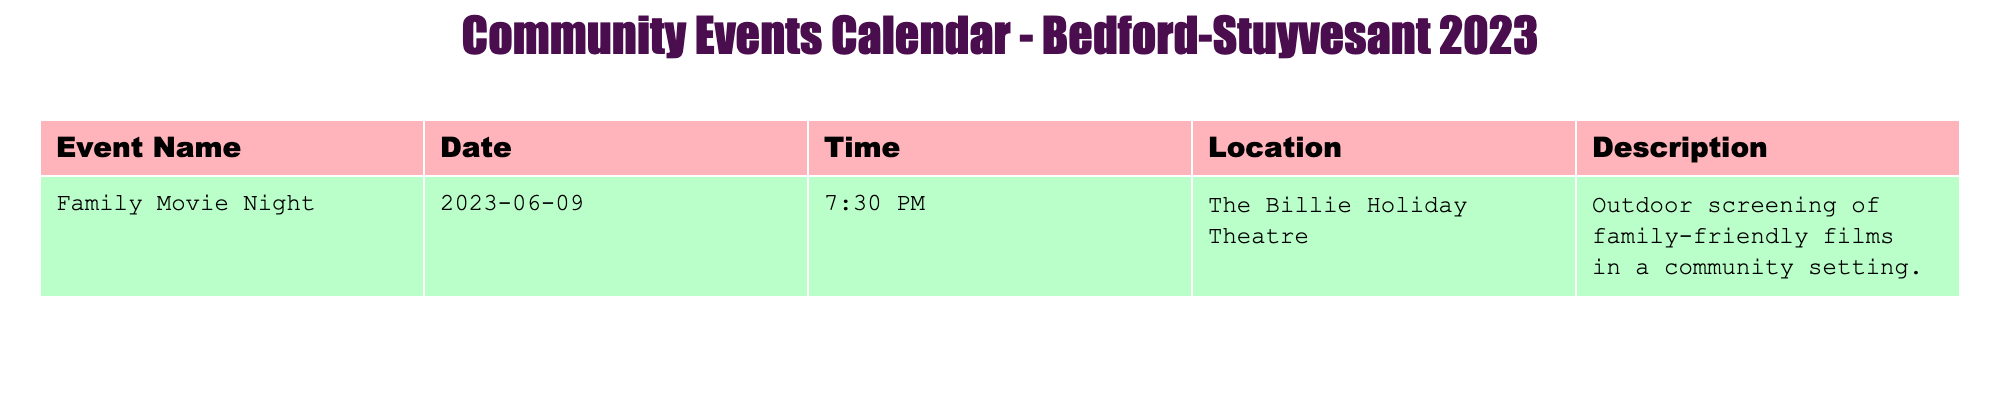What is the name of the event scheduled on June 9, 2023? The event scheduled on June 9, 2023, is listed in the "Event Name" column of the table. It directly states the name as "Family Movie Night."
Answer: Family Movie Night What is the location of the Family Movie Night? By looking at the "Location" column corresponding to "Family Movie Night," it is clear that the event will take place at The Billie Holiday Theatre.
Answer: The Billie Holiday Theatre Is there an outdoor screening mentioned in the description? The "Description" column for "Family Movie Night" includes the phrase "Outdoor screening of family-friendly films," confirming that it is indeed an outdoor event.
Answer: Yes What time does the Family Movie Night start? The "Time" column specifies that the Family Movie Night starts at 7:30 PM, providing a clear answer to the question.
Answer: 7:30 PM How many events are scheduled in the calendar? There is only one event provided in the data. Counting the rows under "Event Name," brings us to a total of one event listed.
Answer: 1 What would be the total number of community events if two more were added? Currently, there is one event listed. If two additional events are added, the new total can be calculated as 1 (current event) + 2 (new events) = 3.
Answer: 3 Did the Family Movie Night happen before 8 PM? The event starts at 7:30 PM, which is before 8 PM, confirming the event's timing in relation to this hour.
Answer: Yes Which event is the sole entry in this schedule? The table only lists one event, which is "Family Movie Night," confirming there are no others on the schedule.
Answer: Family Movie Night Is the Family Movie Night described as a family-friendly event? The description clearly states that it is a "family-friendly" film screening, indicating that it is suitable for families.
Answer: Yes 